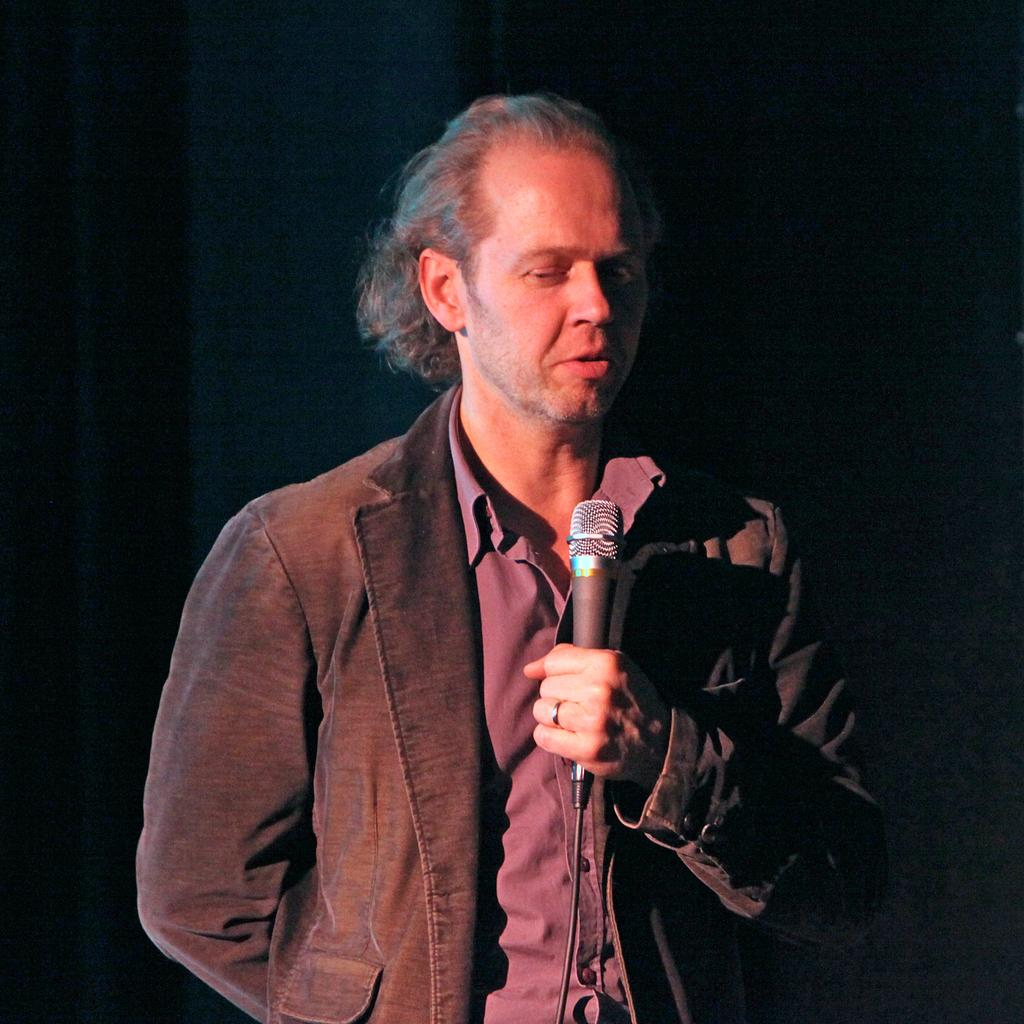Who is the main subject in the image? There is a man in the image. What is the man doing in the image? The man is standing and speaking. What object is the man holding in the image? The man is holding a microphone. What type of action is the man taking with the drawer in the image? There is no drawer present in the image, so the man cannot be taking any action with a drawer. 